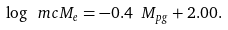<formula> <loc_0><loc_0><loc_500><loc_500>\log { \ m c { M } _ { e } } = - 0 . 4 \ M _ { p g } + 2 . 0 0 .</formula> 